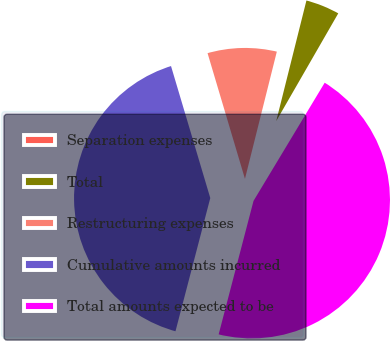<chart> <loc_0><loc_0><loc_500><loc_500><pie_chart><fcel>Separation expenses<fcel>Total<fcel>Restructuring expenses<fcel>Cumulative amounts incurred<fcel>Total amounts expected to be<nl><fcel>0.31%<fcel>4.41%<fcel>8.51%<fcel>41.33%<fcel>45.44%<nl></chart> 